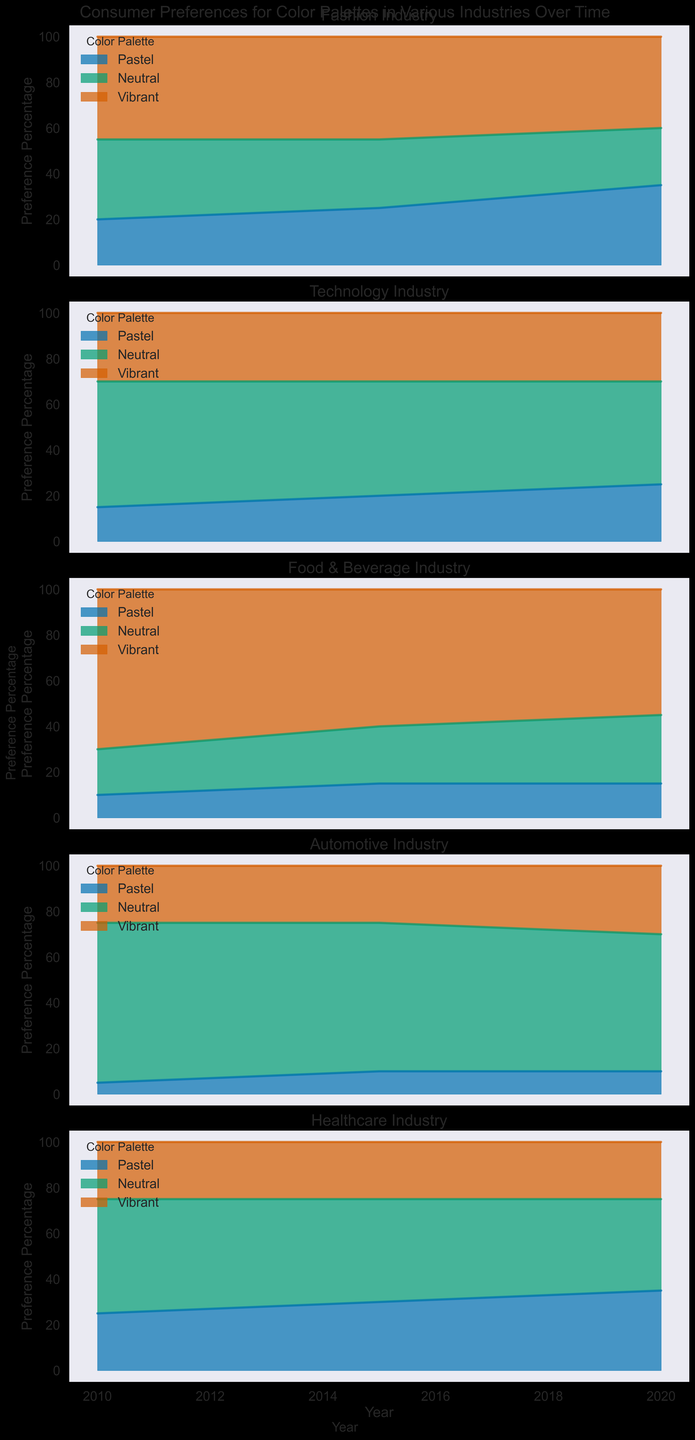Which color palette in the Fashion industry saw the greatest increase in preference percentage from 2010 to 2020? To find the greatest increase in preference, compare the 2010 and 2020 values for each color palette in the Fashion industry. Pastel increased from 20% to 35%, Neutral decreased from 35% to 25%, and Vibrant decreased from 45% to 40%. Therefore, Pastel saw the greatest increase.
Answer: Pastel Between Neutral and Vibrant color palettes in the Technology industry, which had a higher preference percentage in 2010? For the Technology industry in 2010, Neutral had a preference percentage of 55% and Vibrant had 30%. Therefore, Neutral had the higher preference percentage.
Answer: Neutral What is the average preference percentage for the Pastel color palette in the Healthcare industry over 2010, 2015, and 2020? Sum the preference percentages for Pastel in Healthcare over the years (25% in 2010, 30% in 2015, and 35% in 2020) and divide by 3. The sum is 25 + 30 + 35 = 90. The average is 90 / 3 = 30%.
Answer: 30% Which industry had the lowest preference for the Pastel color palette in 2020? Check the preference percentages for Pastel in 2020 across all industries. Fashion has 35%, Technology has 25%, Food & Beverage has 15%, Automotive has 10%, and Healthcare has 35%. The lowest preference is in the Automotive industry.
Answer: Automotive In the Food & Beverage industry, did the preference for Vibrant color palettes increase or decrease from 2010 to 2020? In the Food & Beverage industry, the preference for Vibrant color palettes was 70% in 2010 and 55% in 2020. Since 55% is less than 70%, the preference decreased.
Answer: Decreased Compare the preference for Neutral color palettes in the Automotive industry in 2010 to the total preference for the Pastel palettes in the same industry over 2010, 2015, and 2020. Which is higher? The preference for Neutral in 2010 in the Automotive industry is 70%. The total preference for Pastel over the three years is 5% (2010) + 10% (2015) + 10% (2020), which equals 25%. Therefore, 70% is higher than 25%.
Answer: 70% is higher Which industry had a consistent preference for the Vibrant color palette from 2010 to 2020? Evaluate the preferences for Vibrant color palettes across the years for each industry. The Healthcare industry has unchanged values: 25% in 2010, 25% in 2015, and 25% in 2020, indicating consistency.
Answer: Healthcare What is the combined preference percentage for Neutral and Vibrant color palettes in the Fashion industry in 2020? In 2020, the Neutral preference is 25% and Vibrant preference is 40%. Combine these two values by adding: 25% + 40% = 65%.
Answer: 65% In terms of the preference percentage change, which color palette in the Fashion industry experienced the smallest decrease from 2010 to 2020? For the Fashion industry, Neutral decreased from 35% to 25% (a 10% decrease), and Vibrant decreased from 45% to 40% (a 5% decrease). Pastel increased. Therefore, Vibrant experienced the smallest decrease.
Answer: Vibrant Across all industries, which color palette tends to have higher preference percentages in 2020? Review the highest preference percentages for each color palette across all industries in 2020: Pastel (Fashion 35%), Neutral (Automotive 60%), and Vibrant (Food & Beverage 55%). Neutral's 60% is the highest.
Answer: Neutral 